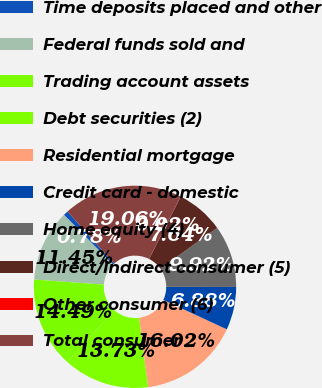Convert chart to OTSL. <chart><loc_0><loc_0><loc_500><loc_500><pie_chart><fcel>Time deposits placed and other<fcel>Federal funds sold and<fcel>Trading account assets<fcel>Debt securities (2)<fcel>Residential mortgage<fcel>Credit card - domestic<fcel>Home equity (4)<fcel>Direct/Indirect consumer (5)<fcel>Other consumer (6)<fcel>Total consumer<nl><fcel>0.78%<fcel>11.45%<fcel>14.49%<fcel>13.73%<fcel>16.02%<fcel>6.88%<fcel>9.92%<fcel>7.64%<fcel>0.02%<fcel>19.06%<nl></chart> 